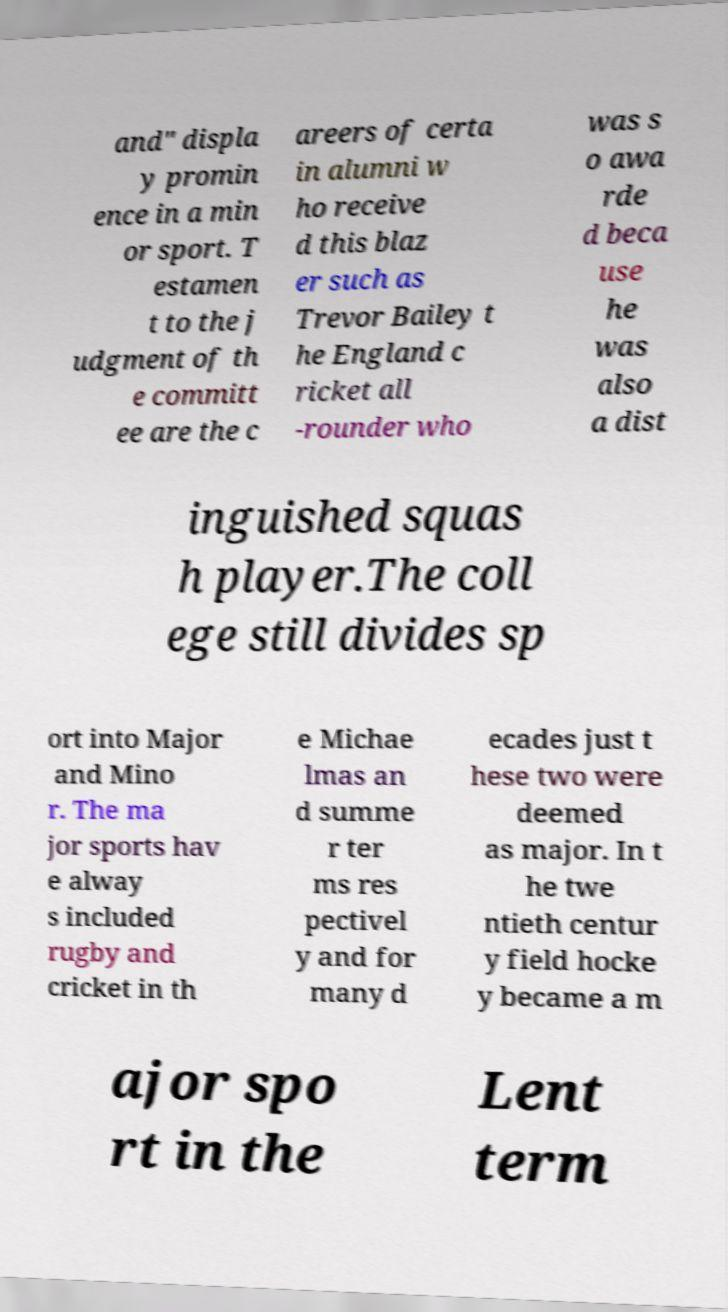Can you read and provide the text displayed in the image?This photo seems to have some interesting text. Can you extract and type it out for me? and" displa y promin ence in a min or sport. T estamen t to the j udgment of th e committ ee are the c areers of certa in alumni w ho receive d this blaz er such as Trevor Bailey t he England c ricket all -rounder who was s o awa rde d beca use he was also a dist inguished squas h player.The coll ege still divides sp ort into Major and Mino r. The ma jor sports hav e alway s included rugby and cricket in th e Michae lmas an d summe r ter ms res pectivel y and for many d ecades just t hese two were deemed as major. In t he twe ntieth centur y field hocke y became a m ajor spo rt in the Lent term 